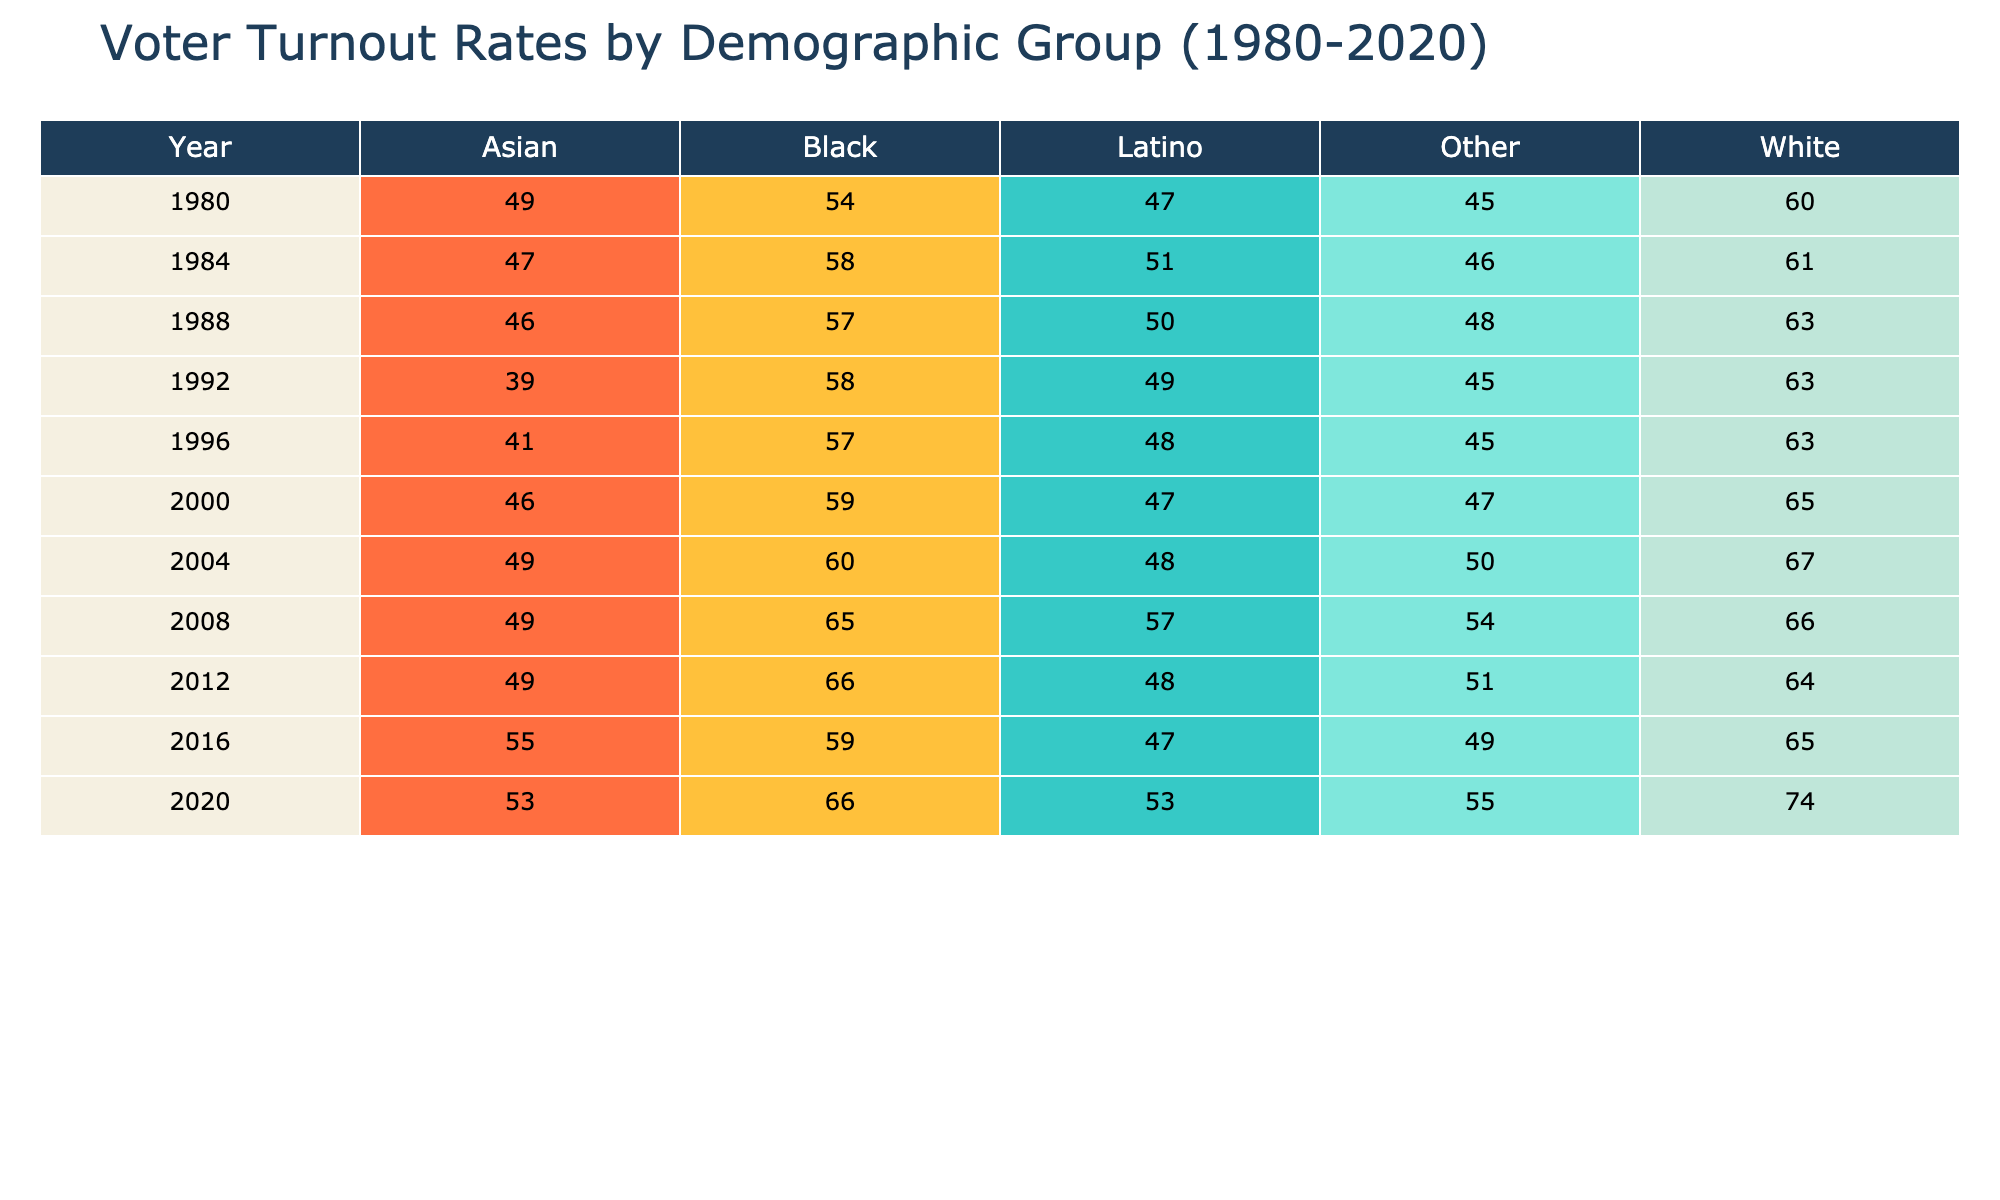What was the voter turnout rate for Black voters in 2008? The table shows that in the row for the year 2008 and the demographic group Black, the voter turnout rate is 65%.
Answer: 65 What demographic group had the highest voter turnout rate in 2020? By examining the year 2020, the table reveals that the White demographic group had the highest voter turnout rate at 74%.
Answer: 74 What was the average voter turnout rate for Latino voters from 1980 to 2020? To find the average, we sum the turnout rates for Latino voters from each year (47 + 51 + 50 + 49 + 47 + 48 + 57 + 48 + 47 + 53) =  475. Then, we divide by the number of years, which is 10. Thus, the average is 475 / 10 = 47.5.
Answer: 47.5 Did Asian voter turnout increase from 2000 to 2008? In the year 2000, the Asian voter turnout rate was 46%, while in 2008 it was 49%. Since 49% is greater than 46%, it confirms that there was an increase.
Answer: Yes Which demographic group had the lowest voter turnout in 1992? Looking at the year 1992, the table indicates that the Latino demographic group had the lowest voter turnout rate at 49%.
Answer: 49 What was the difference in voter turnout rates between White and Black voters in 2012? In 2012, the voter turnout rate for White voters was 64%, and for Black voters, it was 66%. The difference is calculated as 66 - 64 = 2.
Answer: 2 How did the voter turnout rate for the Other demographic change from 1980 to 2020? In 1980, the Other voter turnout rate was 45%, and in 2020 it increased to 55%. The change is calculated as 55 - 45 = 10, indicating an increase.
Answer: Increased by 10 What was the total voter turnout rate for Asian voters across all years in the table? The turnout rates for Asian voters from 1980 to 2020 are (49 + 47 + 46 + 39 + 41 + 46 + 49 + 49 + 55 + 53) =  464. This value represents the total for all years listed.
Answer: 464 Was the voter turnout for Black voters lower than that for White voters in every election year from 1980 to 2016? By examining the table, for the years 1980, 1984, 1988, 1992, 1996, 2000, 2004, 2008, 2012, and 2016, the Black voter turnout was lower than White in 1980, 1984, 1988, 1992, 1996, 2000, 2016 while being equal or higher in the years 2004, 2008, and 2012. Therefore, it is false that Black was lower in every year.
Answer: No 